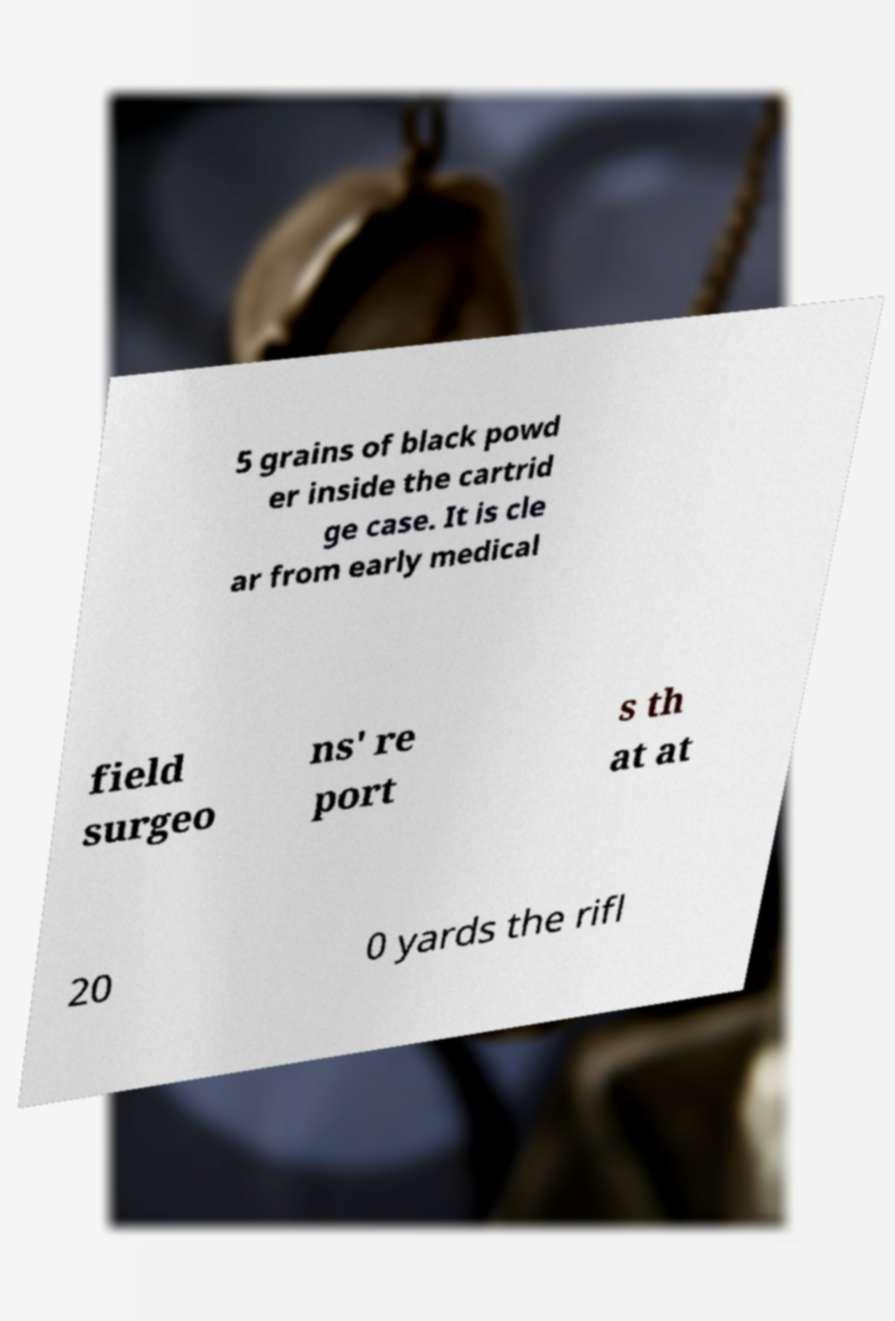Please read and relay the text visible in this image. What does it say? 5 grains of black powd er inside the cartrid ge case. It is cle ar from early medical field surgeo ns' re port s th at at 20 0 yards the rifl 